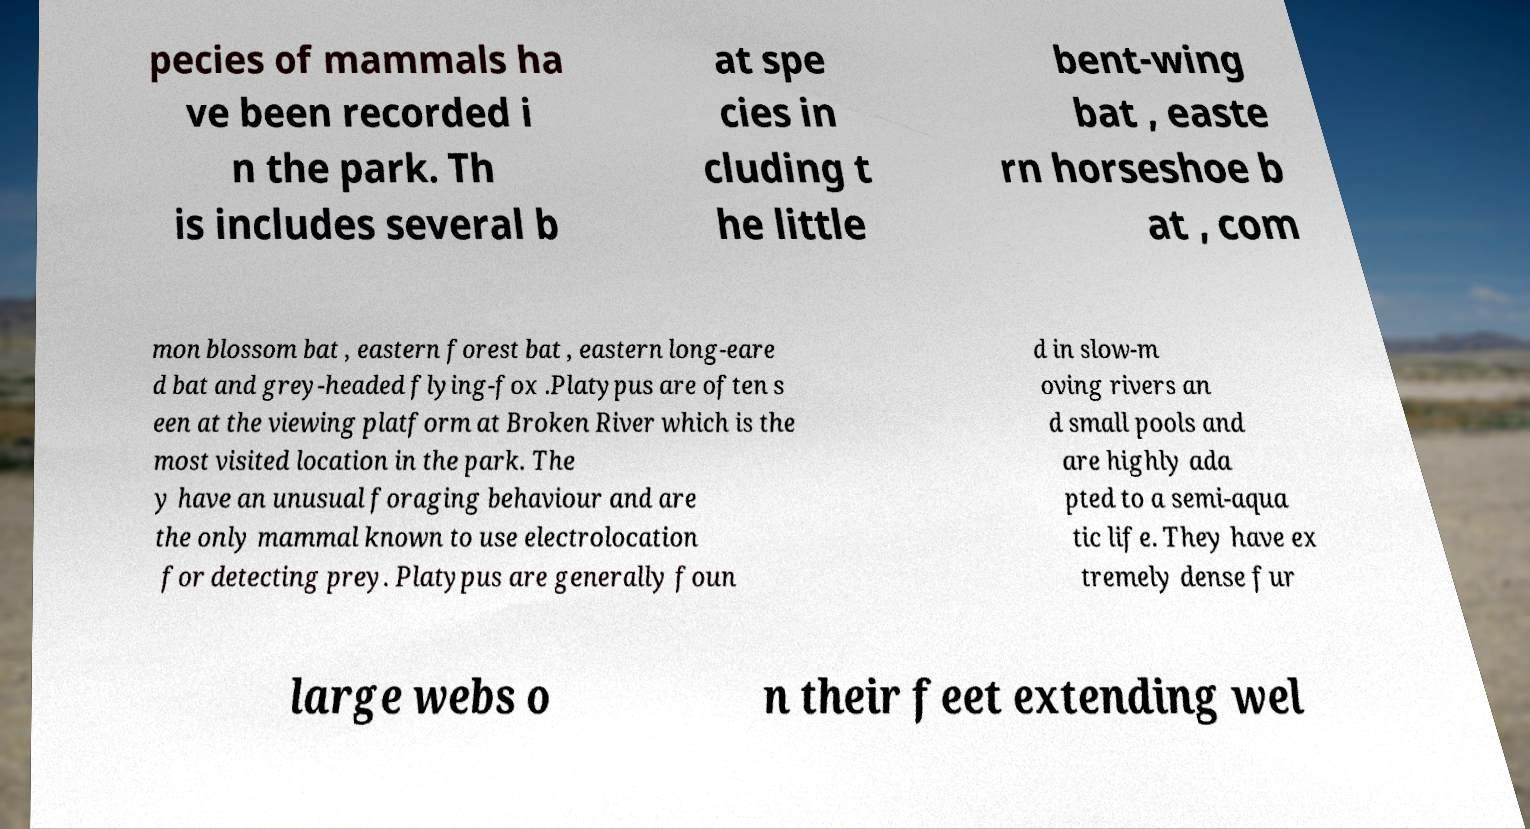Please identify and transcribe the text found in this image. pecies of mammals ha ve been recorded i n the park. Th is includes several b at spe cies in cluding t he little bent-wing bat , easte rn horseshoe b at , com mon blossom bat , eastern forest bat , eastern long-eare d bat and grey-headed flying-fox .Platypus are often s een at the viewing platform at Broken River which is the most visited location in the park. The y have an unusual foraging behaviour and are the only mammal known to use electrolocation for detecting prey. Platypus are generally foun d in slow-m oving rivers an d small pools and are highly ada pted to a semi-aqua tic life. They have ex tremely dense fur large webs o n their feet extending wel 